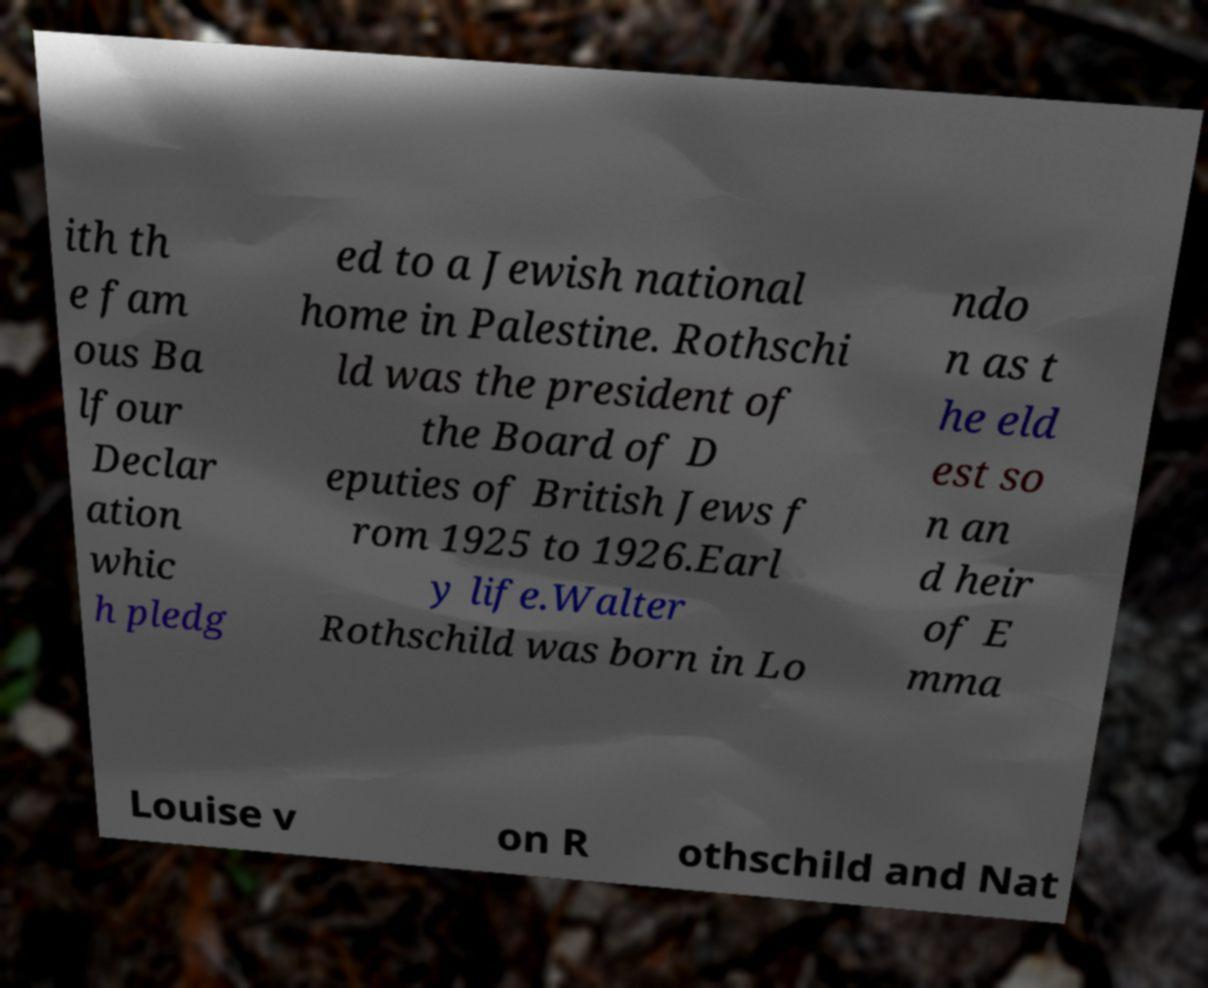Can you accurately transcribe the text from the provided image for me? ith th e fam ous Ba lfour Declar ation whic h pledg ed to a Jewish national home in Palestine. Rothschi ld was the president of the Board of D eputies of British Jews f rom 1925 to 1926.Earl y life.Walter Rothschild was born in Lo ndo n as t he eld est so n an d heir of E mma Louise v on R othschild and Nat 